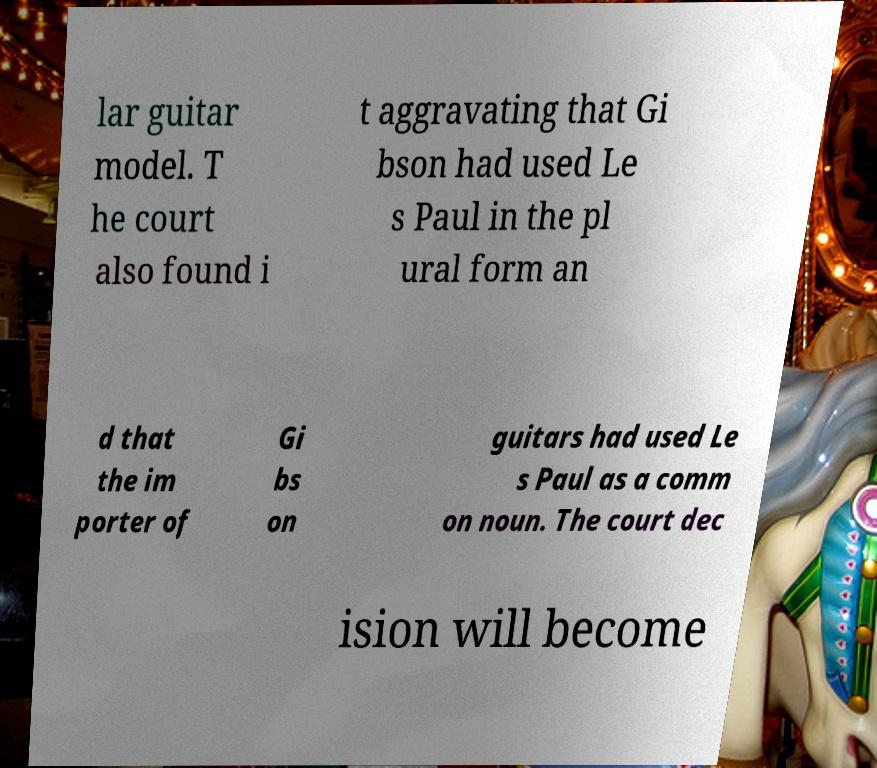Please read and relay the text visible in this image. What does it say? lar guitar model. T he court also found i t aggravating that Gi bson had used Le s Paul in the pl ural form an d that the im porter of Gi bs on guitars had used Le s Paul as a comm on noun. The court dec ision will become 